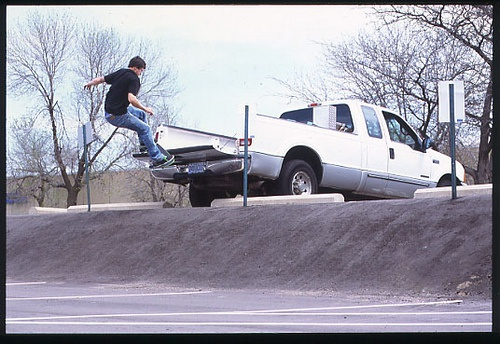Describe the objects in this image and their specific colors. I can see truck in black, white, gray, and darkgray tones, people in black and gray tones, and skateboard in black, gray, darkgray, and white tones in this image. 